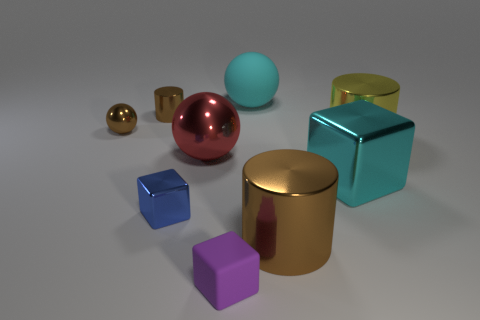How many brown cylinders must be subtracted to get 1 brown cylinders? 1 Subtract all cubes. How many objects are left? 6 Subtract 0 yellow spheres. How many objects are left? 9 Subtract all large blocks. Subtract all tiny blocks. How many objects are left? 6 Add 8 large red metal balls. How many large red metal balls are left? 9 Add 1 tiny gray rubber blocks. How many tiny gray rubber blocks exist? 1 